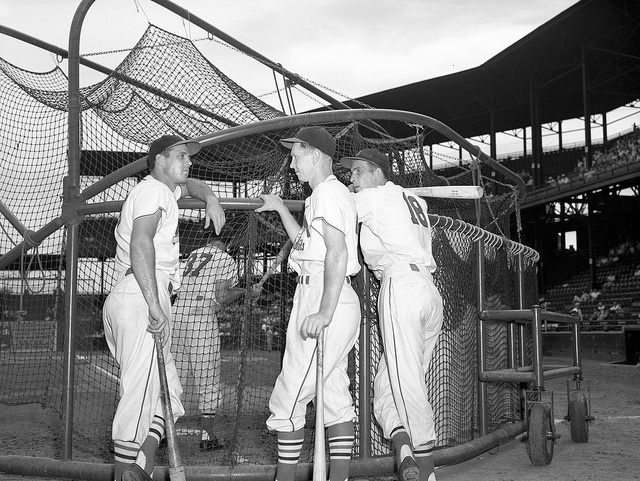Describe the objects in this image and their specific colors. I can see people in white, lightgray, gray, darkgray, and black tones, people in white, lightgray, darkgray, gray, and black tones, people in white, lightgray, gray, darkgray, and black tones, people in white, darkgray, gray, lightgray, and black tones, and baseball bat in lightgray, darkgray, gray, and white tones in this image. 